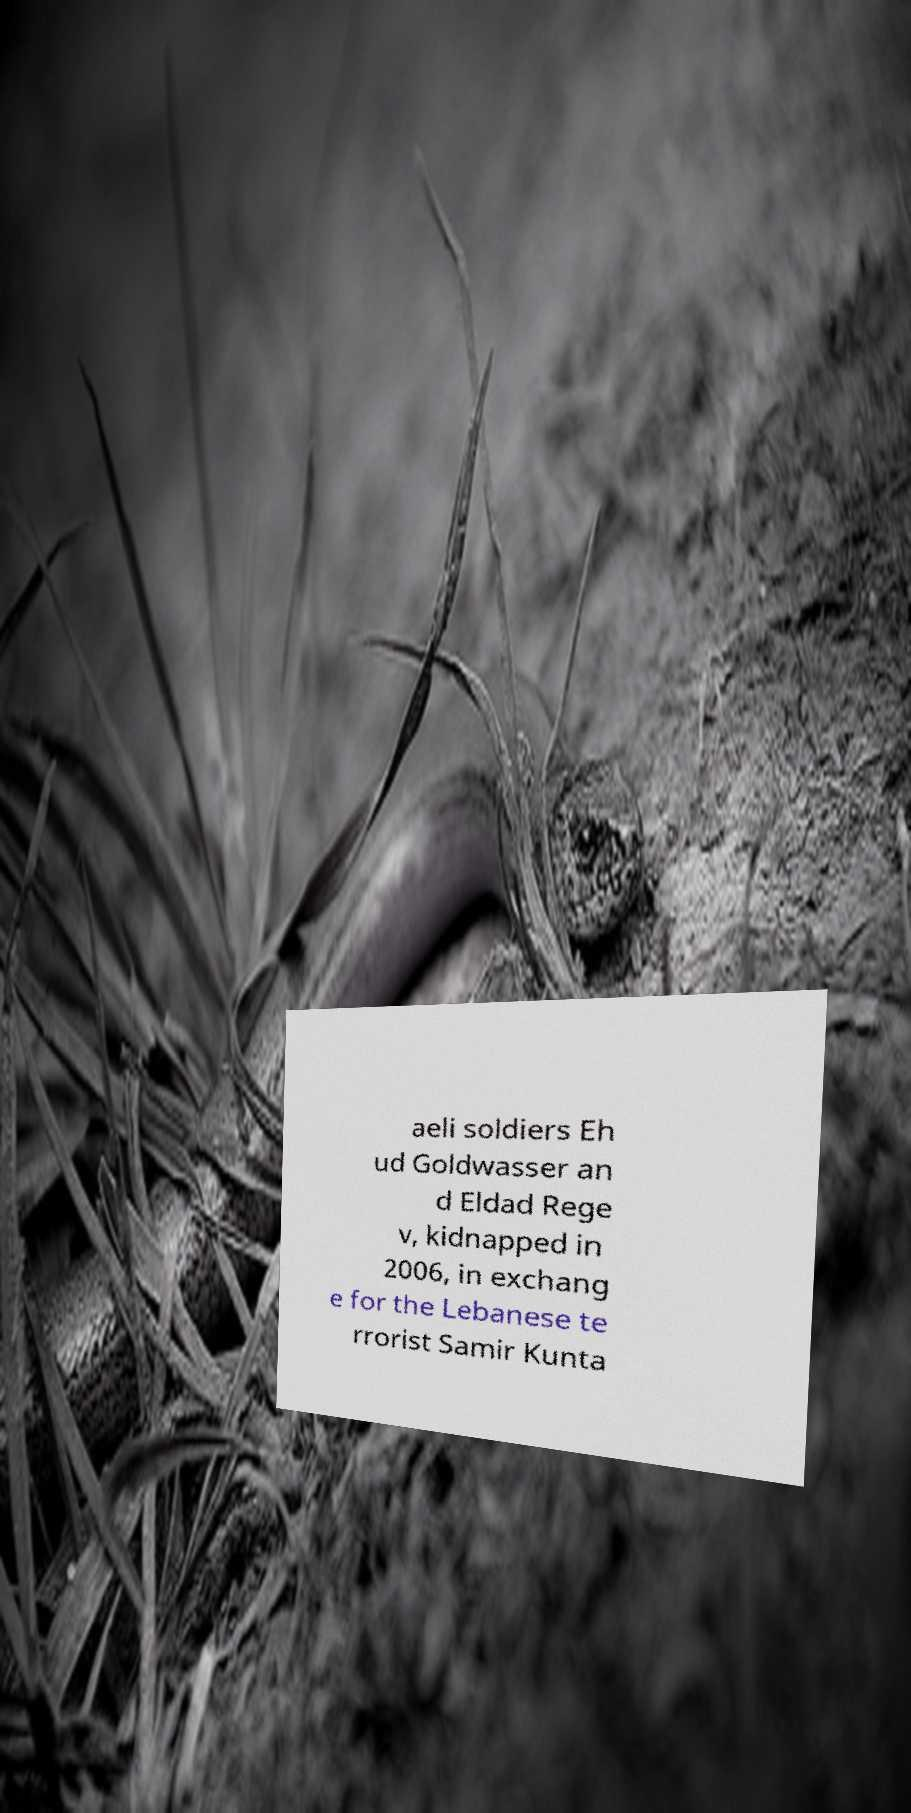What messages or text are displayed in this image? I need them in a readable, typed format. aeli soldiers Eh ud Goldwasser an d Eldad Rege v, kidnapped in 2006, in exchang e for the Lebanese te rrorist Samir Kunta 